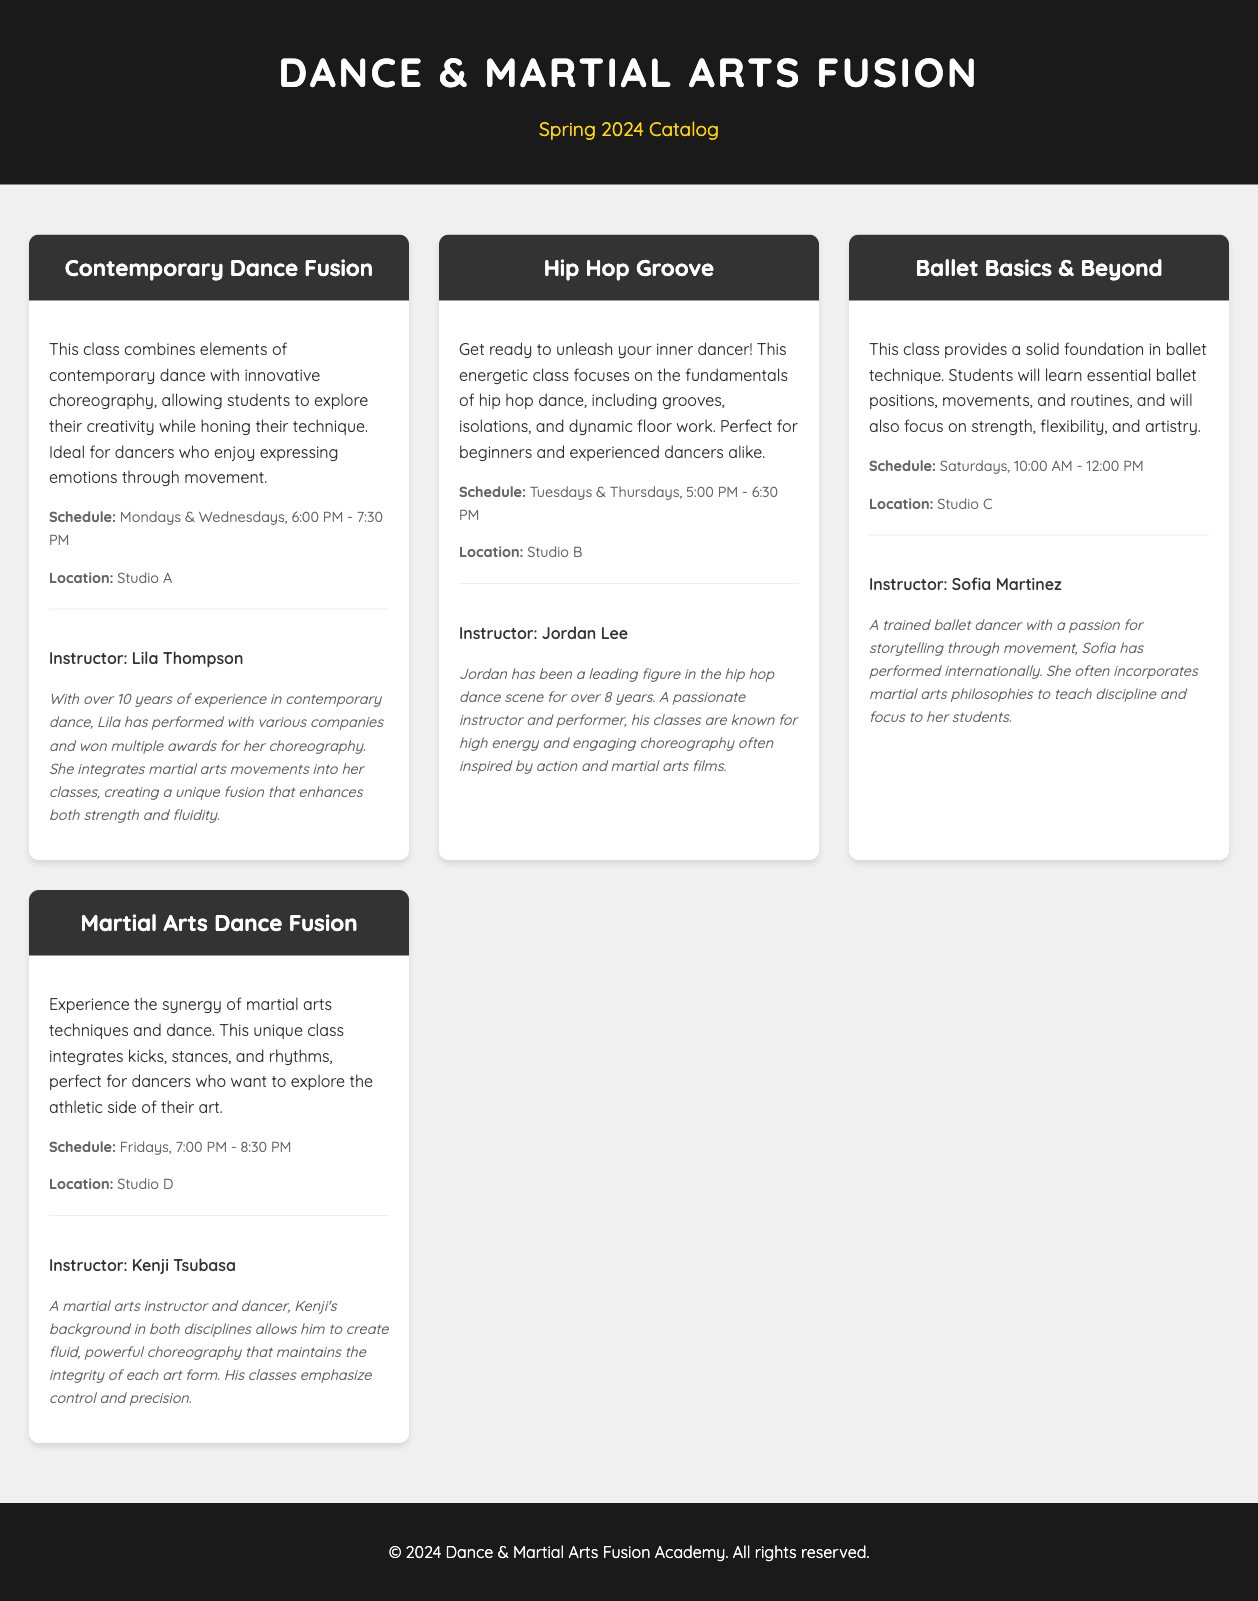What is the name of the ballet class? The ballet class is titled "Ballet Basics & Beyond."
Answer: Ballet Basics & Beyond Who teaches the Contemporary Dance Fusion class? The instructor for Contemporary Dance Fusion is Lila Thompson.
Answer: Lila Thompson What day and time does the Hip Hop Groove class occur? The Hip Hop Groove class is scheduled for Tuesdays & Thursdays at 5:00 PM - 6:30 PM.
Answer: Tuesdays & Thursdays, 5:00 PM - 6:30 PM Which studio hosts the Martial Arts Dance Fusion class? The Martial Arts Dance Fusion class takes place in Studio D.
Answer: Studio D How many years of experience does Kenji Tsubasa have in martial arts and dance? The document does not specify the number of years Kenji Tsubasa has experience but states he is a martial arts instructor and dancer.
Answer: Not specified What is the focus of the Martial Arts Dance Fusion class? The focus of the Martial Arts Dance Fusion class is to integrate martial arts techniques with dance.
Answer: Integrate martial arts techniques with dance Which class is known for high energy and engaging choreography? The Hip Hop Groove class is known for high energy and engaging choreography.
Answer: Hip Hop Groove When does the Ballet Basics & Beyond class occur? The Ballet Basics & Beyond class occurs on Saturdays at 10:00 AM - 12:00 PM.
Answer: Saturdays, 10:00 AM - 12:00 PM What kind of choreography does Lila Thompson integrate into her classes? Lila Thompson integrates martial arts movements into her choreography.
Answer: Martial arts movements 